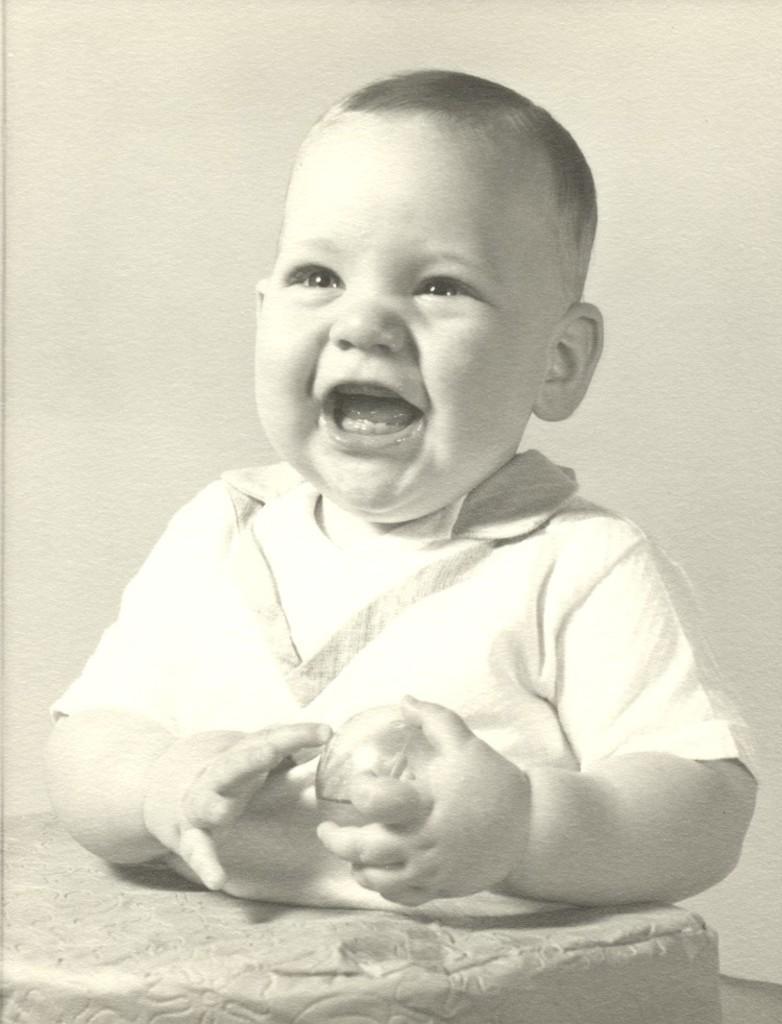How would you summarize this image in a sentence or two? In this image I can see a baby and I can see he is holding an object. 